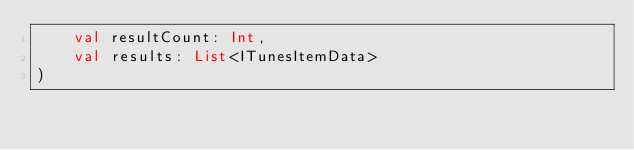<code> <loc_0><loc_0><loc_500><loc_500><_Kotlin_>    val resultCount: Int,
    val results: List<ITunesItemData>
)</code> 